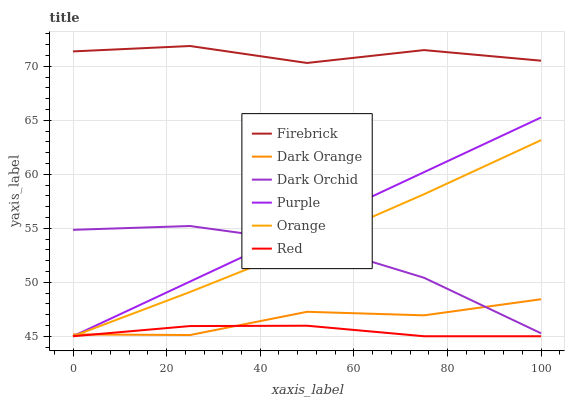Does Red have the minimum area under the curve?
Answer yes or no. Yes. Does Firebrick have the maximum area under the curve?
Answer yes or no. Yes. Does Purple have the minimum area under the curve?
Answer yes or no. No. Does Purple have the maximum area under the curve?
Answer yes or no. No. Is Purple the smoothest?
Answer yes or no. Yes. Is Firebrick the roughest?
Answer yes or no. Yes. Is Firebrick the smoothest?
Answer yes or no. No. Is Purple the roughest?
Answer yes or no. No. Does Purple have the lowest value?
Answer yes or no. Yes. Does Firebrick have the lowest value?
Answer yes or no. No. Does Firebrick have the highest value?
Answer yes or no. Yes. Does Purple have the highest value?
Answer yes or no. No. Is Orange less than Firebrick?
Answer yes or no. Yes. Is Dark Orchid greater than Red?
Answer yes or no. Yes. Does Orange intersect Purple?
Answer yes or no. Yes. Is Orange less than Purple?
Answer yes or no. No. Is Orange greater than Purple?
Answer yes or no. No. Does Orange intersect Firebrick?
Answer yes or no. No. 